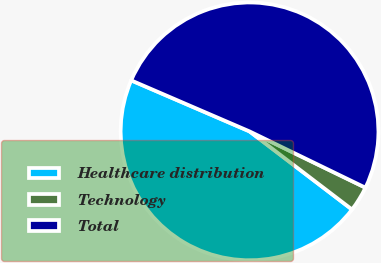Convert chart to OTSL. <chart><loc_0><loc_0><loc_500><loc_500><pie_chart><fcel>Healthcare distribution<fcel>Technology<fcel>Total<nl><fcel>46.11%<fcel>3.17%<fcel>50.72%<nl></chart> 